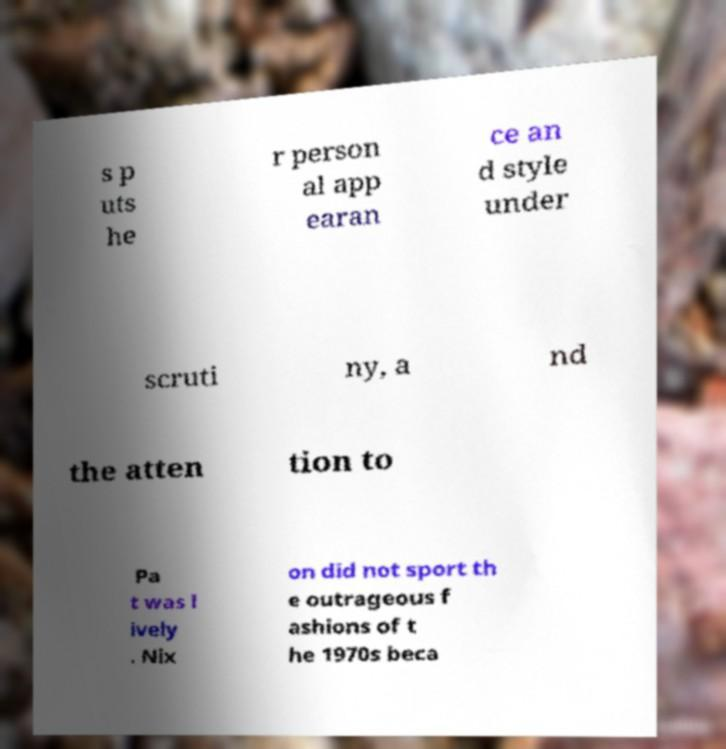Could you assist in decoding the text presented in this image and type it out clearly? s p uts he r person al app earan ce an d style under scruti ny, a nd the atten tion to Pa t was l ively . Nix on did not sport th e outrageous f ashions of t he 1970s beca 